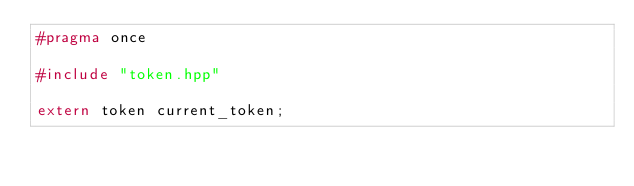<code> <loc_0><loc_0><loc_500><loc_500><_C++_>#pragma once

#include "token.hpp"

extern token current_token;</code> 